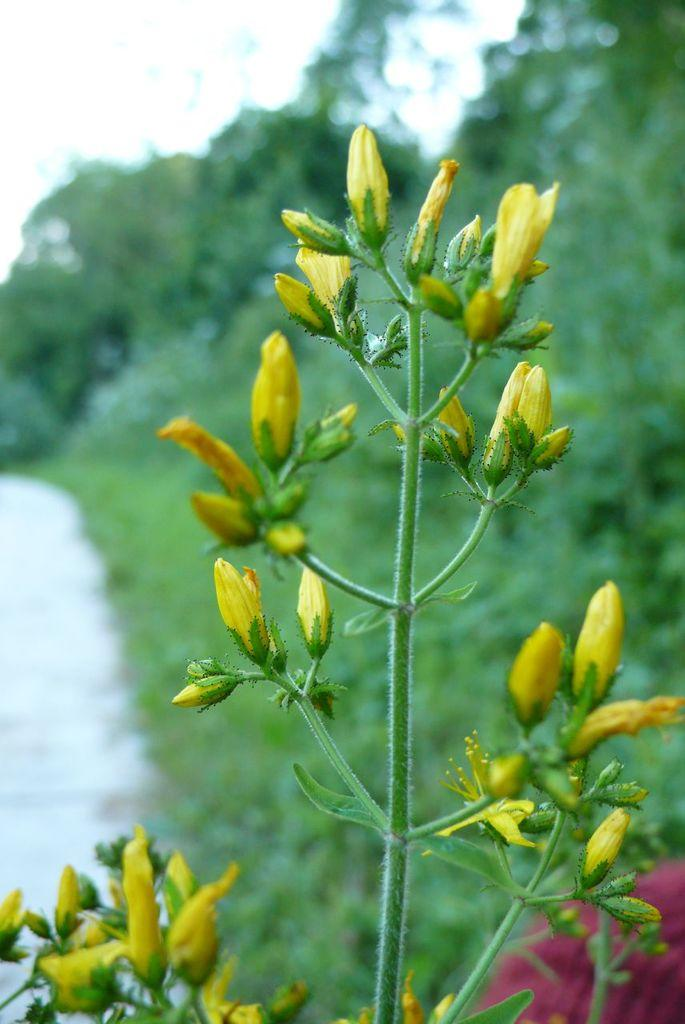What is present on the stem in the image? There are buds and leaves present on a stem in the image. Can you describe the background of the image? There may be trees visible in the background of the image. How would you describe the sky in the image? The sky appears to be clear in the image. Are there any pests visible on the leaves in the image? There is no mention of pests in the image, so we cannot determine if any are present. 